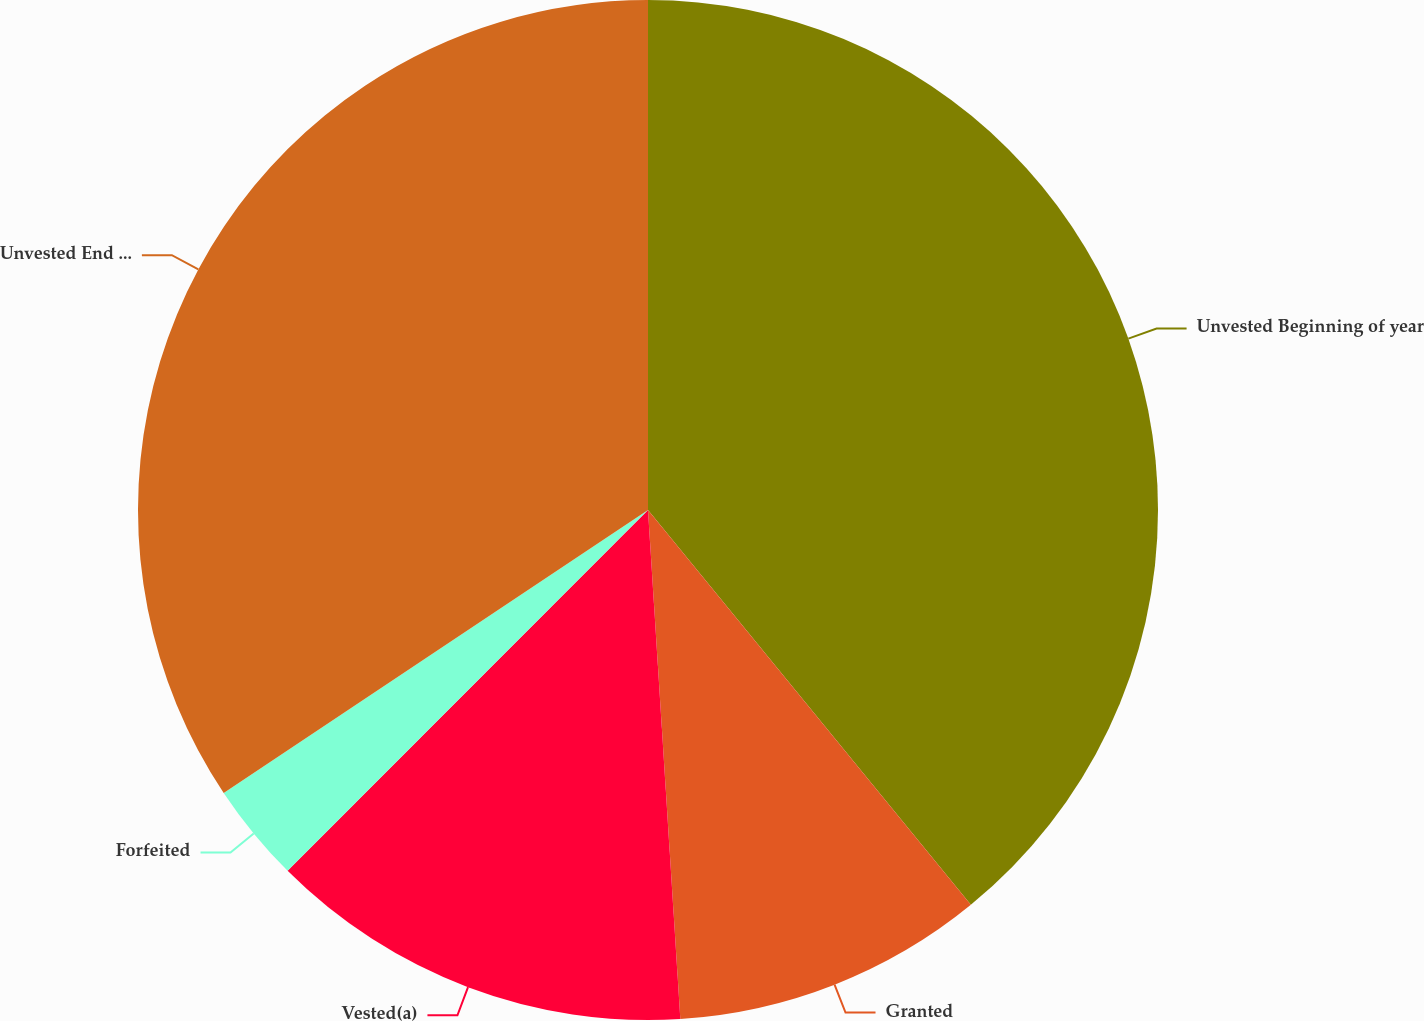Convert chart to OTSL. <chart><loc_0><loc_0><loc_500><loc_500><pie_chart><fcel>Unvested Beginning of year<fcel>Granted<fcel>Vested(a)<fcel>Forfeited<fcel>Unvested End of year<nl><fcel>39.09%<fcel>9.9%<fcel>13.5%<fcel>3.15%<fcel>34.36%<nl></chart> 